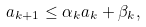<formula> <loc_0><loc_0><loc_500><loc_500>a _ { k + 1 } \leq \alpha _ { k } a _ { k } + \beta _ { k } ,</formula> 